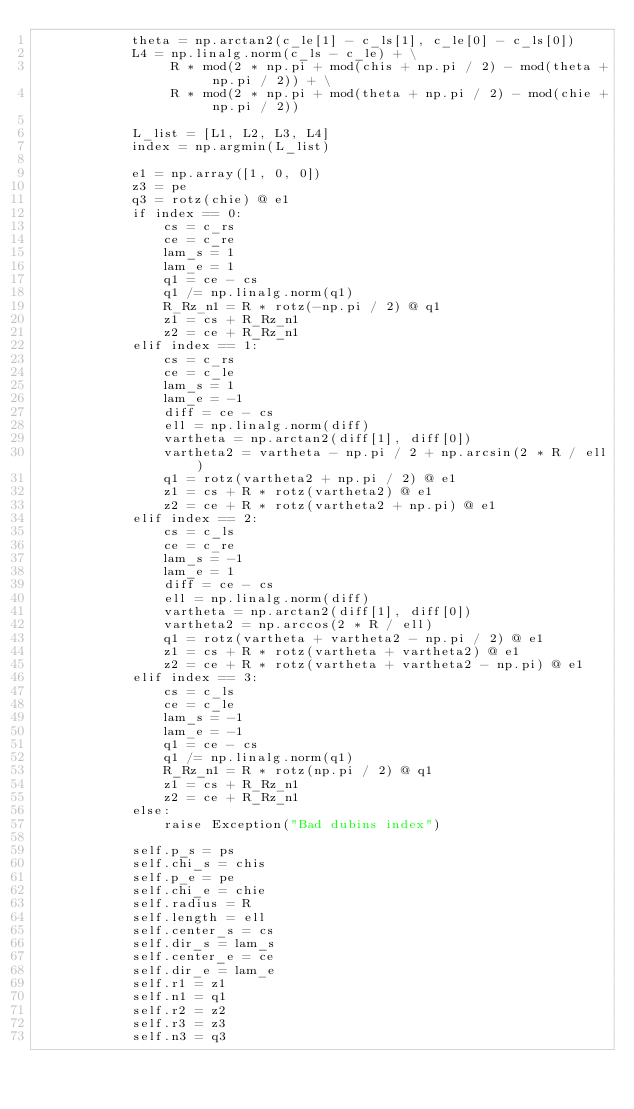Convert code to text. <code><loc_0><loc_0><loc_500><loc_500><_Python_>            theta = np.arctan2(c_le[1] - c_ls[1], c_le[0] - c_ls[0])
            L4 = np.linalg.norm(c_ls - c_le) + \
                 R * mod(2 * np.pi + mod(chis + np.pi / 2) - mod(theta + np.pi / 2)) + \
                 R * mod(2 * np.pi + mod(theta + np.pi / 2) - mod(chie + np.pi / 2))

            L_list = [L1, L2, L3, L4]
            index = np.argmin(L_list)

            e1 = np.array([1, 0, 0])
            z3 = pe
            q3 = rotz(chie) @ e1
            if index == 0:
                cs = c_rs
                ce = c_re
                lam_s = 1
                lam_e = 1
                q1 = ce - cs
                q1 /= np.linalg.norm(q1)
                R_Rz_n1 = R * rotz(-np.pi / 2) @ q1
                z1 = cs + R_Rz_n1
                z2 = ce + R_Rz_n1
            elif index == 1:
                cs = c_rs
                ce = c_le
                lam_s = 1
                lam_e = -1
                diff = ce - cs
                ell = np.linalg.norm(diff)
                vartheta = np.arctan2(diff[1], diff[0])
                vartheta2 = vartheta - np.pi / 2 + np.arcsin(2 * R / ell)
                q1 = rotz(vartheta2 + np.pi / 2) @ e1
                z1 = cs + R * rotz(vartheta2) @ e1
                z2 = ce + R * rotz(vartheta2 + np.pi) @ e1
            elif index == 2:
                cs = c_ls
                ce = c_re
                lam_s = -1
                lam_e = 1
                diff = ce - cs
                ell = np.linalg.norm(diff)
                vartheta = np.arctan2(diff[1], diff[0])
                vartheta2 = np.arccos(2 * R / ell)
                q1 = rotz(vartheta + vartheta2 - np.pi / 2) @ e1
                z1 = cs + R * rotz(vartheta + vartheta2) @ e1
                z2 = ce + R * rotz(vartheta + vartheta2 - np.pi) @ e1
            elif index == 3:
                cs = c_ls
                ce = c_le
                lam_s = -1
                lam_e = -1
                q1 = ce - cs
                q1 /= np.linalg.norm(q1)
                R_Rz_n1 = R * rotz(np.pi / 2) @ q1
                z1 = cs + R_Rz_n1
                z2 = ce + R_Rz_n1
            else:
                raise Exception("Bad dubins index")

            self.p_s = ps
            self.chi_s = chis
            self.p_e = pe
            self.chi_e = chie
            self.radius = R
            self.length = ell
            self.center_s = cs
            self.dir_s = lam_s
            self.center_e = ce
            self.dir_e = lam_e
            self.r1 = z1
            self.n1 = q1
            self.r2 = z2
            self.r3 = z3
            self.n3 = q3
</code> 